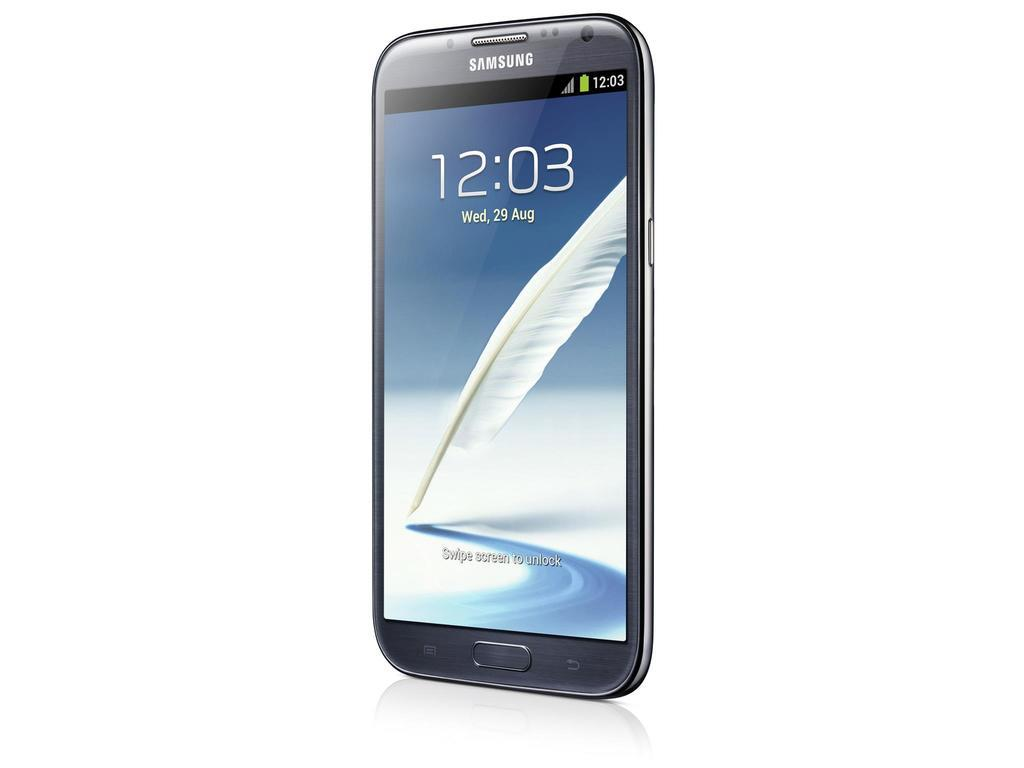<image>
Render a clear and concise summary of the photo. A Samsung galaxy phone displaying 12:03 on Wednesday August 29th with a feather as the background 